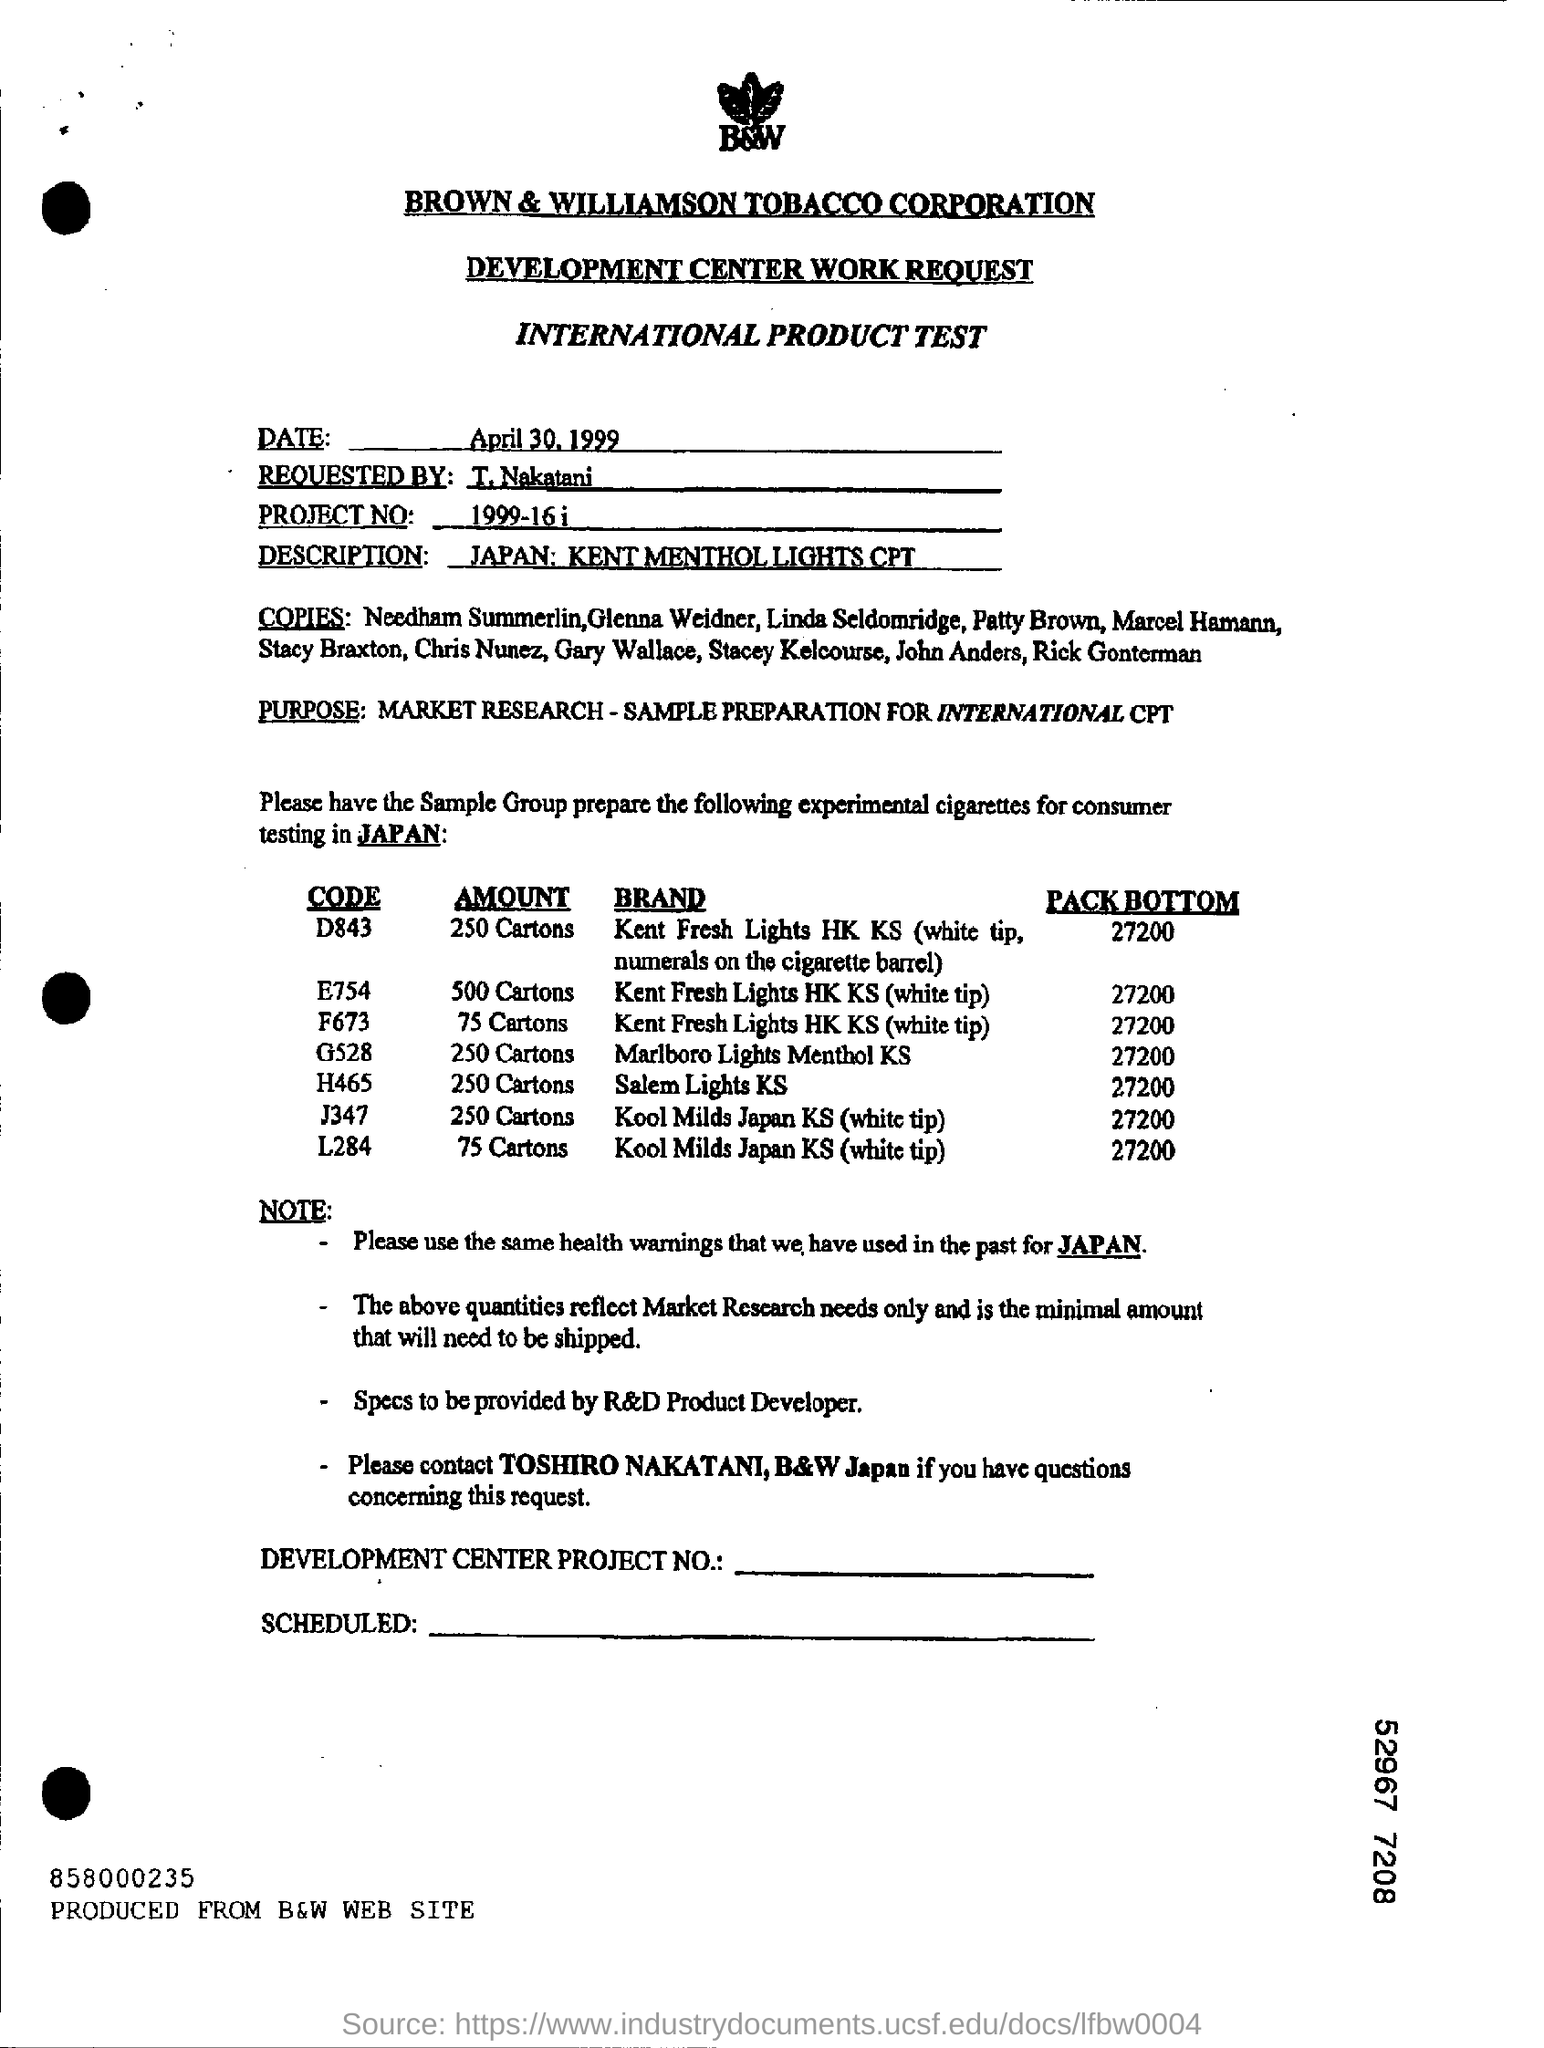Identify some key points in this picture. The code for Salem Lights KS is H465. The product test was requested by T. Nakatani. The project number is 1999-16. 